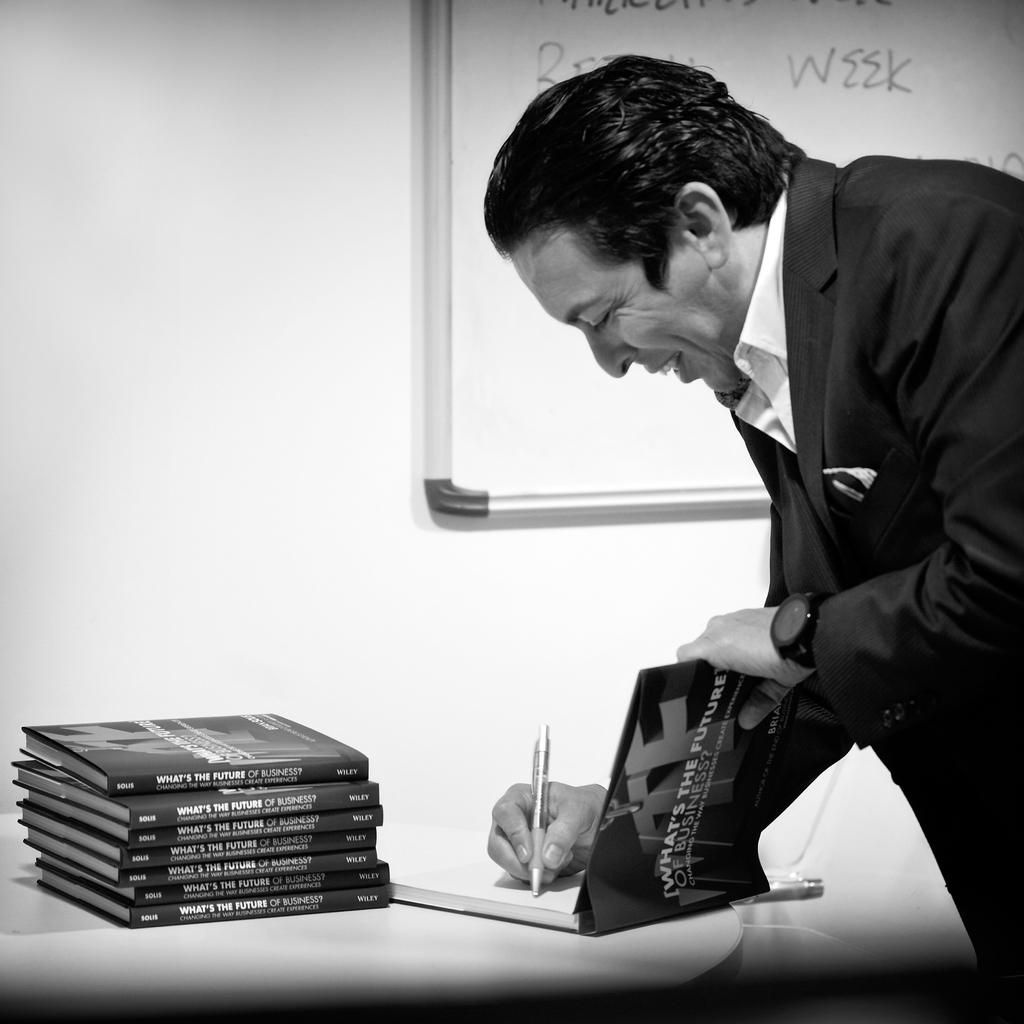Provide a one-sentence caption for the provided image. A man signing a book titled What's The Future of Business. 